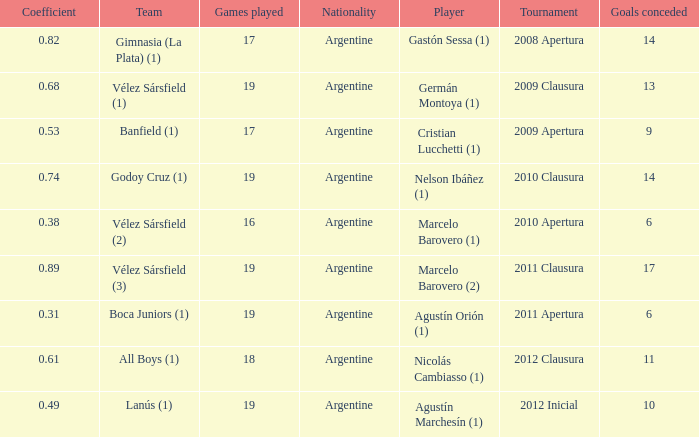 the 2010 clausura tournament? 0.74. 